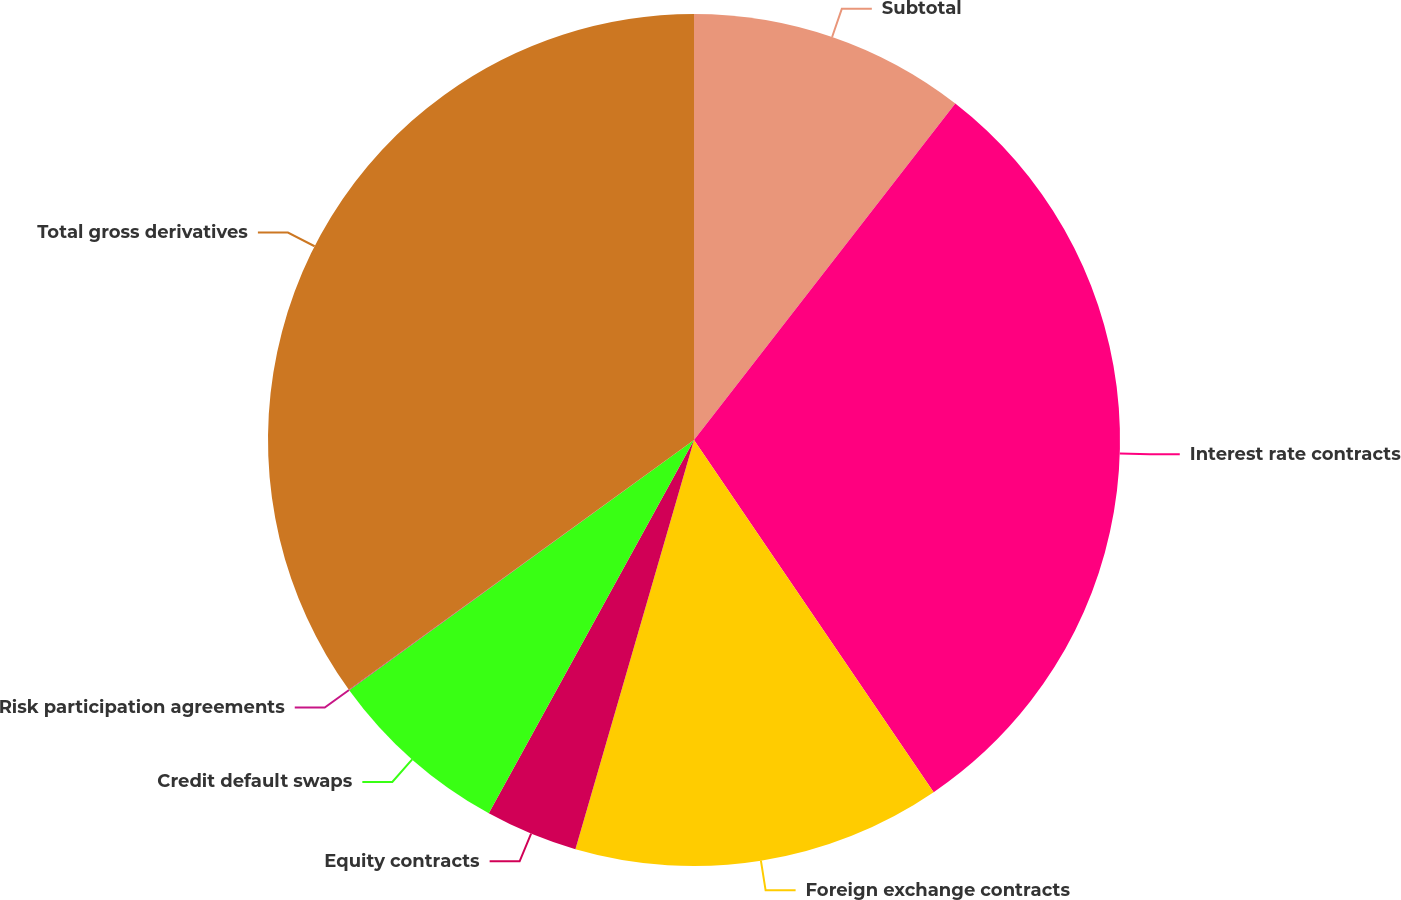Convert chart to OTSL. <chart><loc_0><loc_0><loc_500><loc_500><pie_chart><fcel>Subtotal<fcel>Interest rate contracts<fcel>Foreign exchange contracts<fcel>Equity contracts<fcel>Credit default swaps<fcel>Risk participation agreements<fcel>Total gross derivatives<nl><fcel>10.51%<fcel>29.98%<fcel>14.0%<fcel>3.51%<fcel>7.01%<fcel>0.02%<fcel>34.97%<nl></chart> 